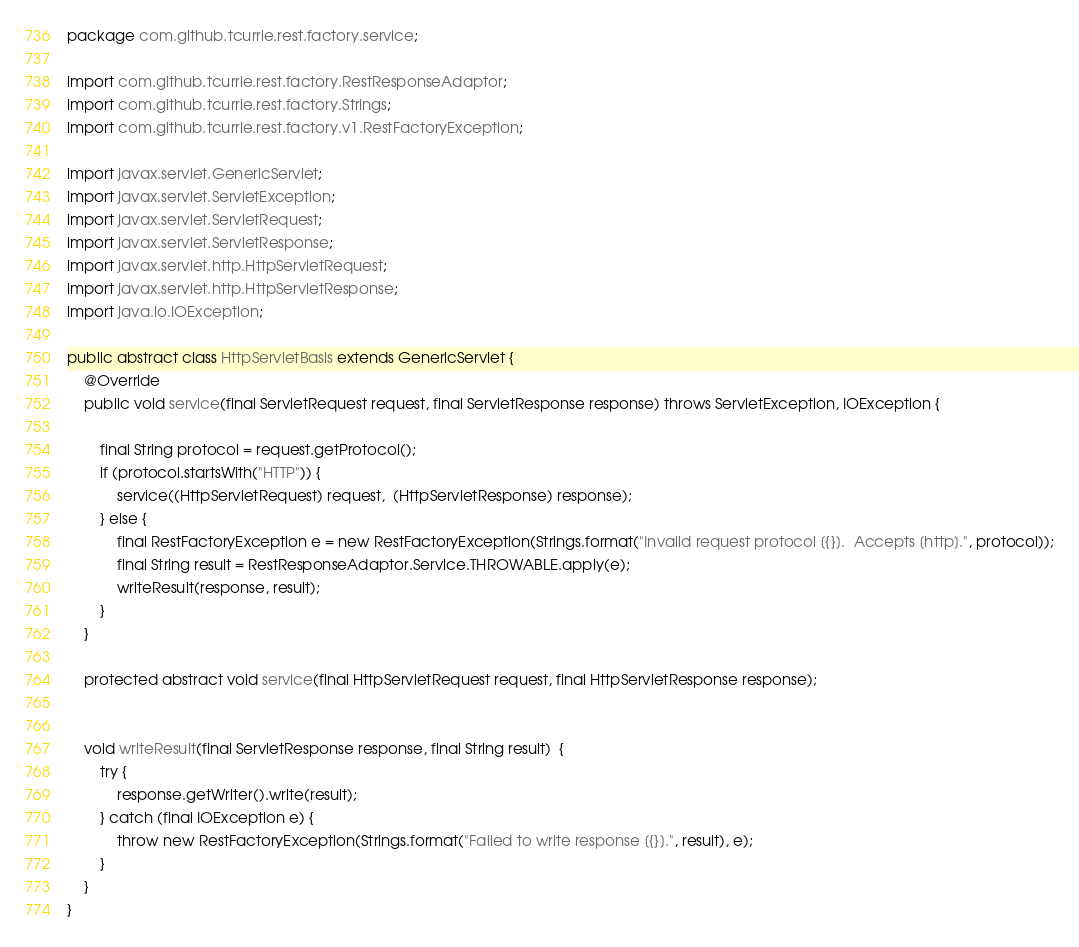<code> <loc_0><loc_0><loc_500><loc_500><_Java_>package com.github.tcurrie.rest.factory.service;

import com.github.tcurrie.rest.factory.RestResponseAdaptor;
import com.github.tcurrie.rest.factory.Strings;
import com.github.tcurrie.rest.factory.v1.RestFactoryException;

import javax.servlet.GenericServlet;
import javax.servlet.ServletException;
import javax.servlet.ServletRequest;
import javax.servlet.ServletResponse;
import javax.servlet.http.HttpServletRequest;
import javax.servlet.http.HttpServletResponse;
import java.io.IOException;

public abstract class HttpServletBasis extends GenericServlet {
    @Override
    public void service(final ServletRequest request, final ServletResponse response) throws ServletException, IOException {

        final String protocol = request.getProtocol();
        if (protocol.startsWith("HTTP")) {
            service((HttpServletRequest) request,  (HttpServletResponse) response);
        } else {
            final RestFactoryException e = new RestFactoryException(Strings.format("Invalid request protocol [{}].  Accepts [http].", protocol));
            final String result = RestResponseAdaptor.Service.THROWABLE.apply(e);
            writeResult(response, result);
        }
    }

    protected abstract void service(final HttpServletRequest request, final HttpServletResponse response);


    void writeResult(final ServletResponse response, final String result)  {
        try {
            response.getWriter().write(result);
        } catch (final IOException e) {
            throw new RestFactoryException(Strings.format("Failed to write response [{}].", result), e);
        }
    }
}
</code> 